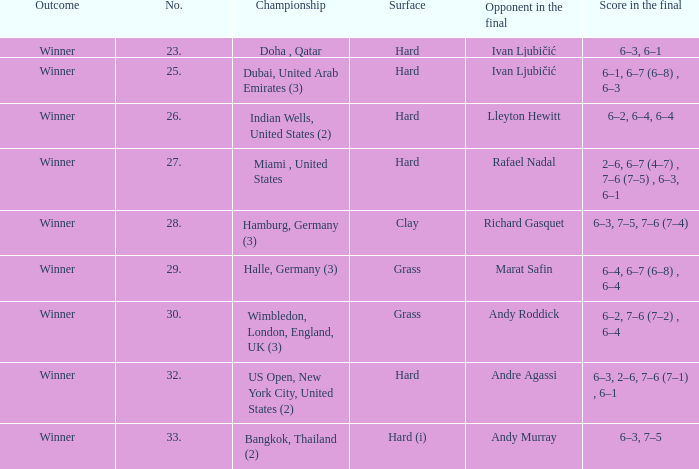In the championship Indian Wells, United States (2), who are the opponents in the final? Lleyton Hewitt. 